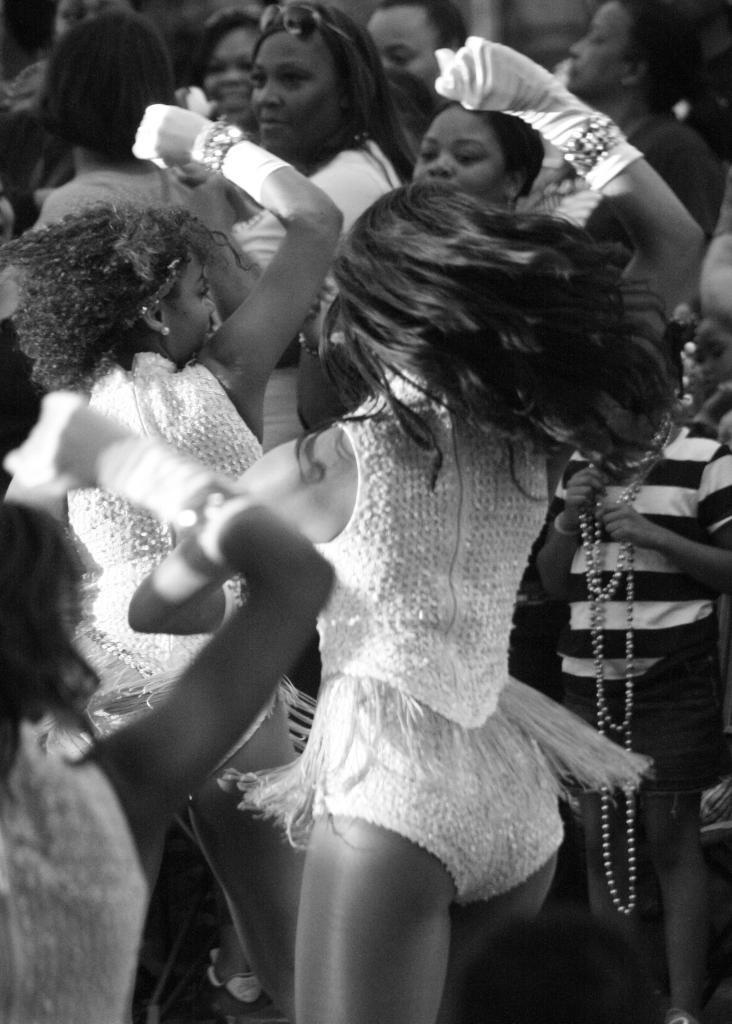How would you summarize this image in a sentence or two? In this image we can see few people are dancing, There are few people standing in the image. 